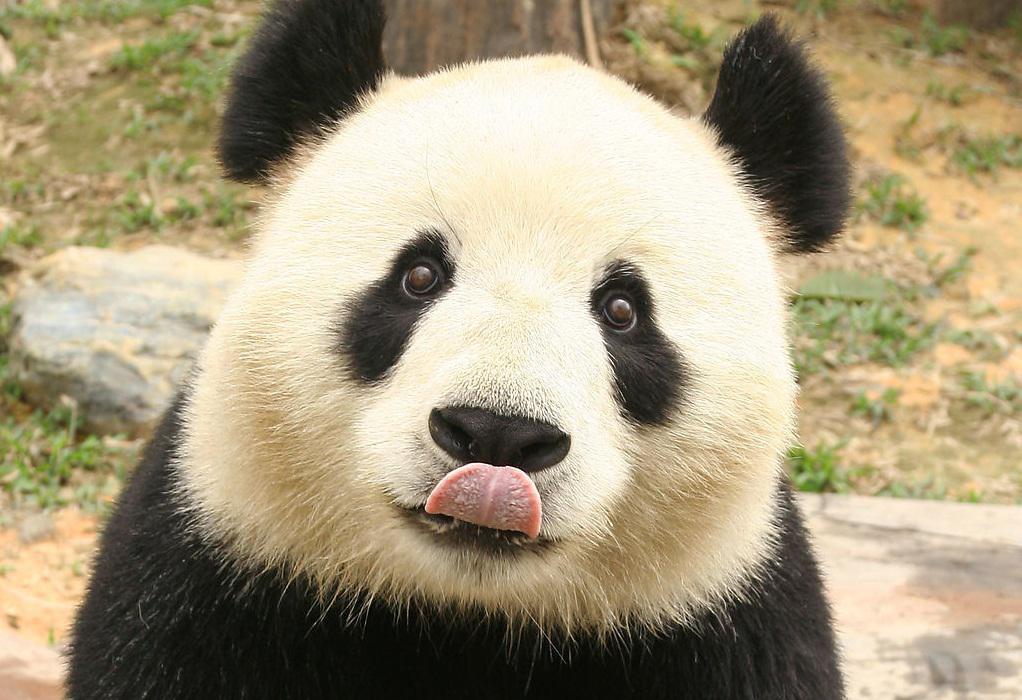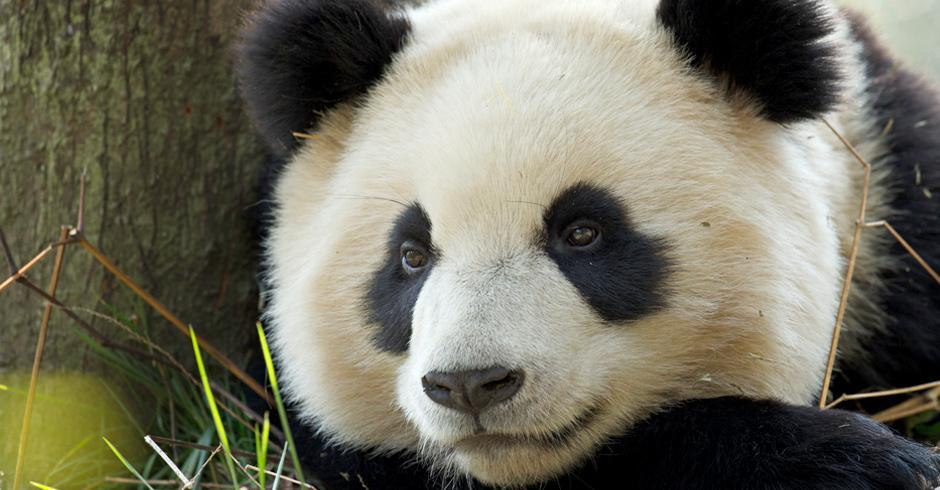The first image is the image on the left, the second image is the image on the right. Considering the images on both sides, is "In one of the images, a single panda is looking straight at the camera with its tongue visible." valid? Answer yes or no. Yes. The first image is the image on the left, the second image is the image on the right. Given the left and right images, does the statement "Both of one panda's front paws are extended forward and visible." hold true? Answer yes or no. No. 